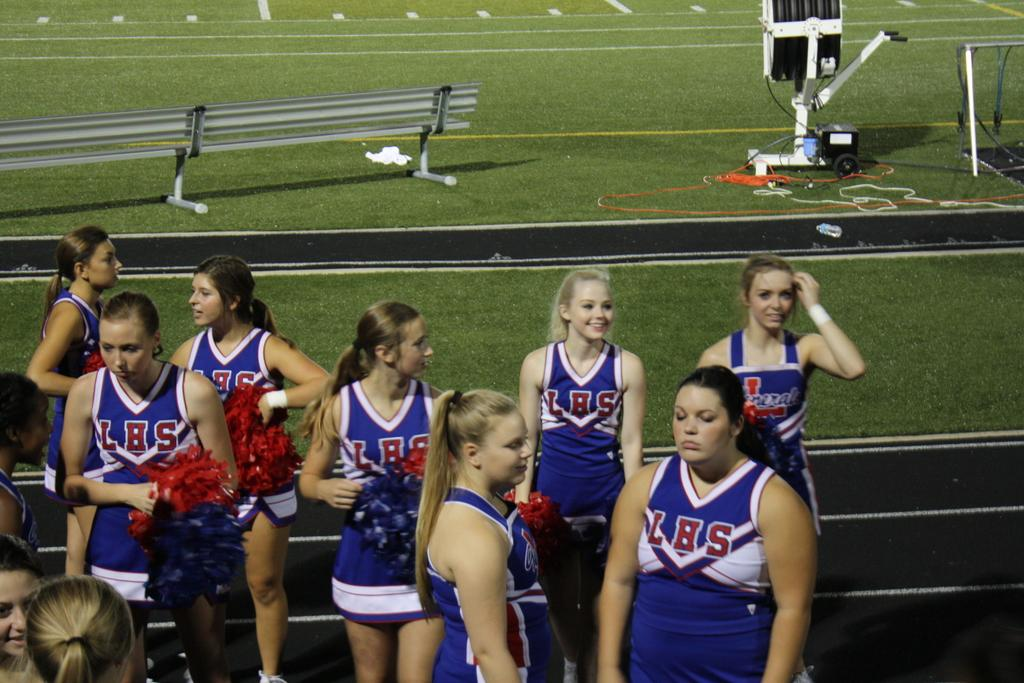<image>
Write a terse but informative summary of the picture. LHS cheerleaders are standing in uniform by the sidelines 